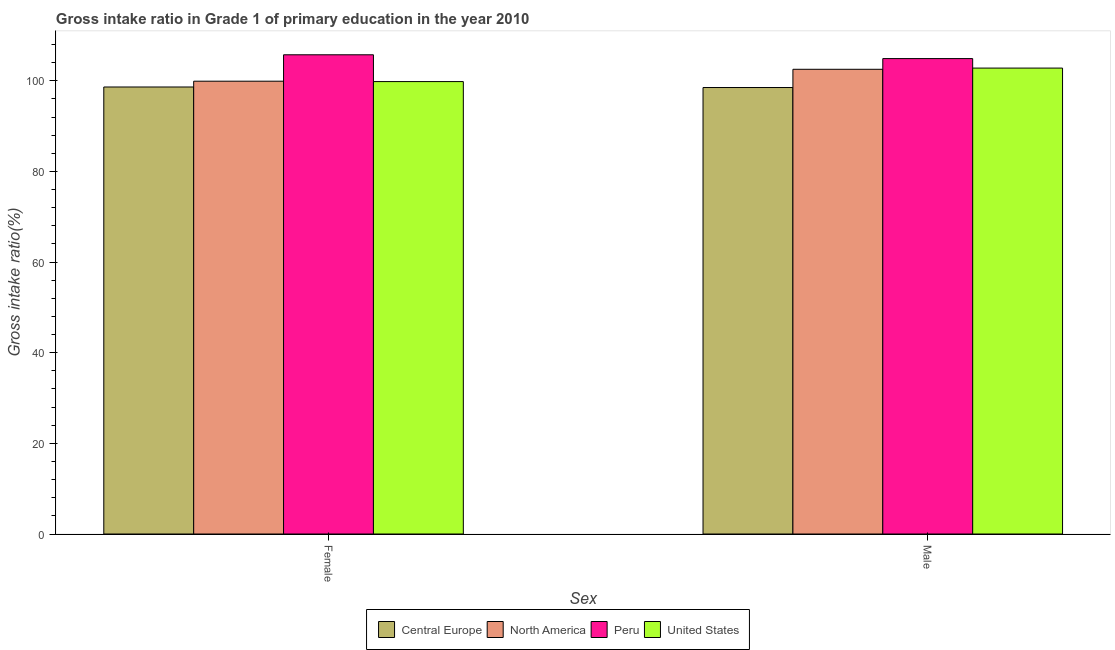How many groups of bars are there?
Provide a short and direct response. 2. Are the number of bars on each tick of the X-axis equal?
Provide a short and direct response. Yes. How many bars are there on the 2nd tick from the left?
Your response must be concise. 4. What is the gross intake ratio(male) in North America?
Make the answer very short. 102.54. Across all countries, what is the maximum gross intake ratio(female)?
Your answer should be compact. 105.74. Across all countries, what is the minimum gross intake ratio(female)?
Your answer should be compact. 98.63. In which country was the gross intake ratio(male) minimum?
Keep it short and to the point. Central Europe. What is the total gross intake ratio(male) in the graph?
Offer a very short reply. 408.75. What is the difference between the gross intake ratio(male) in United States and that in North America?
Give a very brief answer. 0.27. What is the difference between the gross intake ratio(female) in North America and the gross intake ratio(male) in Peru?
Provide a short and direct response. -4.99. What is the average gross intake ratio(female) per country?
Offer a very short reply. 101.02. What is the difference between the gross intake ratio(male) and gross intake ratio(female) in United States?
Provide a succinct answer. 2.98. What is the ratio of the gross intake ratio(male) in Peru to that in Central Europe?
Make the answer very short. 1.06. In how many countries, is the gross intake ratio(female) greater than the average gross intake ratio(female) taken over all countries?
Provide a succinct answer. 1. What does the 1st bar from the left in Female represents?
Provide a short and direct response. Central Europe. What does the 2nd bar from the right in Male represents?
Your answer should be compact. Peru. What is the difference between two consecutive major ticks on the Y-axis?
Make the answer very short. 20. Are the values on the major ticks of Y-axis written in scientific E-notation?
Provide a succinct answer. No. Does the graph contain any zero values?
Make the answer very short. No. How are the legend labels stacked?
Provide a succinct answer. Horizontal. What is the title of the graph?
Make the answer very short. Gross intake ratio in Grade 1 of primary education in the year 2010. Does "Antigua and Barbuda" appear as one of the legend labels in the graph?
Offer a very short reply. No. What is the label or title of the X-axis?
Your answer should be very brief. Sex. What is the label or title of the Y-axis?
Your response must be concise. Gross intake ratio(%). What is the Gross intake ratio(%) in Central Europe in Female?
Provide a short and direct response. 98.63. What is the Gross intake ratio(%) in North America in Female?
Your answer should be very brief. 99.91. What is the Gross intake ratio(%) of Peru in Female?
Your answer should be compact. 105.74. What is the Gross intake ratio(%) of United States in Female?
Your answer should be compact. 99.82. What is the Gross intake ratio(%) in Central Europe in Male?
Make the answer very short. 98.51. What is the Gross intake ratio(%) of North America in Male?
Provide a short and direct response. 102.54. What is the Gross intake ratio(%) of Peru in Male?
Offer a terse response. 104.9. What is the Gross intake ratio(%) in United States in Male?
Ensure brevity in your answer.  102.8. Across all Sex, what is the maximum Gross intake ratio(%) in Central Europe?
Make the answer very short. 98.63. Across all Sex, what is the maximum Gross intake ratio(%) of North America?
Give a very brief answer. 102.54. Across all Sex, what is the maximum Gross intake ratio(%) of Peru?
Keep it short and to the point. 105.74. Across all Sex, what is the maximum Gross intake ratio(%) in United States?
Provide a short and direct response. 102.8. Across all Sex, what is the minimum Gross intake ratio(%) in Central Europe?
Ensure brevity in your answer.  98.51. Across all Sex, what is the minimum Gross intake ratio(%) of North America?
Your answer should be very brief. 99.91. Across all Sex, what is the minimum Gross intake ratio(%) in Peru?
Provide a succinct answer. 104.9. Across all Sex, what is the minimum Gross intake ratio(%) of United States?
Ensure brevity in your answer.  99.82. What is the total Gross intake ratio(%) of Central Europe in the graph?
Offer a very short reply. 197.14. What is the total Gross intake ratio(%) of North America in the graph?
Keep it short and to the point. 202.45. What is the total Gross intake ratio(%) in Peru in the graph?
Offer a terse response. 210.63. What is the total Gross intake ratio(%) in United States in the graph?
Ensure brevity in your answer.  202.63. What is the difference between the Gross intake ratio(%) of Central Europe in Female and that in Male?
Your answer should be very brief. 0.12. What is the difference between the Gross intake ratio(%) of North America in Female and that in Male?
Your answer should be compact. -2.63. What is the difference between the Gross intake ratio(%) of Peru in Female and that in Male?
Make the answer very short. 0.84. What is the difference between the Gross intake ratio(%) of United States in Female and that in Male?
Your answer should be compact. -2.98. What is the difference between the Gross intake ratio(%) of Central Europe in Female and the Gross intake ratio(%) of North America in Male?
Keep it short and to the point. -3.91. What is the difference between the Gross intake ratio(%) in Central Europe in Female and the Gross intake ratio(%) in Peru in Male?
Ensure brevity in your answer.  -6.27. What is the difference between the Gross intake ratio(%) of Central Europe in Female and the Gross intake ratio(%) of United States in Male?
Your answer should be very brief. -4.17. What is the difference between the Gross intake ratio(%) of North America in Female and the Gross intake ratio(%) of Peru in Male?
Offer a very short reply. -4.99. What is the difference between the Gross intake ratio(%) in North America in Female and the Gross intake ratio(%) in United States in Male?
Keep it short and to the point. -2.89. What is the difference between the Gross intake ratio(%) in Peru in Female and the Gross intake ratio(%) in United States in Male?
Give a very brief answer. 2.93. What is the average Gross intake ratio(%) in Central Europe per Sex?
Give a very brief answer. 98.57. What is the average Gross intake ratio(%) of North America per Sex?
Your answer should be very brief. 101.22. What is the average Gross intake ratio(%) in Peru per Sex?
Offer a terse response. 105.32. What is the average Gross intake ratio(%) in United States per Sex?
Make the answer very short. 101.31. What is the difference between the Gross intake ratio(%) of Central Europe and Gross intake ratio(%) of North America in Female?
Ensure brevity in your answer.  -1.28. What is the difference between the Gross intake ratio(%) in Central Europe and Gross intake ratio(%) in Peru in Female?
Offer a terse response. -7.11. What is the difference between the Gross intake ratio(%) in Central Europe and Gross intake ratio(%) in United States in Female?
Provide a succinct answer. -1.19. What is the difference between the Gross intake ratio(%) of North America and Gross intake ratio(%) of Peru in Female?
Make the answer very short. -5.83. What is the difference between the Gross intake ratio(%) in North America and Gross intake ratio(%) in United States in Female?
Offer a terse response. 0.09. What is the difference between the Gross intake ratio(%) of Peru and Gross intake ratio(%) of United States in Female?
Offer a very short reply. 5.91. What is the difference between the Gross intake ratio(%) in Central Europe and Gross intake ratio(%) in North America in Male?
Offer a terse response. -4.02. What is the difference between the Gross intake ratio(%) of Central Europe and Gross intake ratio(%) of Peru in Male?
Your answer should be compact. -6.38. What is the difference between the Gross intake ratio(%) in Central Europe and Gross intake ratio(%) in United States in Male?
Give a very brief answer. -4.29. What is the difference between the Gross intake ratio(%) of North America and Gross intake ratio(%) of Peru in Male?
Provide a succinct answer. -2.36. What is the difference between the Gross intake ratio(%) of North America and Gross intake ratio(%) of United States in Male?
Offer a terse response. -0.27. What is the difference between the Gross intake ratio(%) in Peru and Gross intake ratio(%) in United States in Male?
Give a very brief answer. 2.09. What is the ratio of the Gross intake ratio(%) of Central Europe in Female to that in Male?
Provide a succinct answer. 1. What is the ratio of the Gross intake ratio(%) of North America in Female to that in Male?
Ensure brevity in your answer.  0.97. What is the difference between the highest and the second highest Gross intake ratio(%) in Central Europe?
Ensure brevity in your answer.  0.12. What is the difference between the highest and the second highest Gross intake ratio(%) of North America?
Provide a succinct answer. 2.63. What is the difference between the highest and the second highest Gross intake ratio(%) of Peru?
Offer a very short reply. 0.84. What is the difference between the highest and the second highest Gross intake ratio(%) of United States?
Provide a short and direct response. 2.98. What is the difference between the highest and the lowest Gross intake ratio(%) in Central Europe?
Give a very brief answer. 0.12. What is the difference between the highest and the lowest Gross intake ratio(%) in North America?
Keep it short and to the point. 2.63. What is the difference between the highest and the lowest Gross intake ratio(%) in Peru?
Give a very brief answer. 0.84. What is the difference between the highest and the lowest Gross intake ratio(%) in United States?
Your answer should be compact. 2.98. 